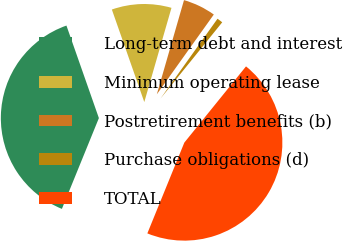Convert chart to OTSL. <chart><loc_0><loc_0><loc_500><loc_500><pie_chart><fcel>Long-term debt and interest<fcel>Minimum operating lease<fcel>Postretirement benefits (b)<fcel>Purchase obligations (d)<fcel>TOTAL<nl><fcel>38.48%<fcel>9.84%<fcel>5.4%<fcel>0.96%<fcel>45.33%<nl></chart> 